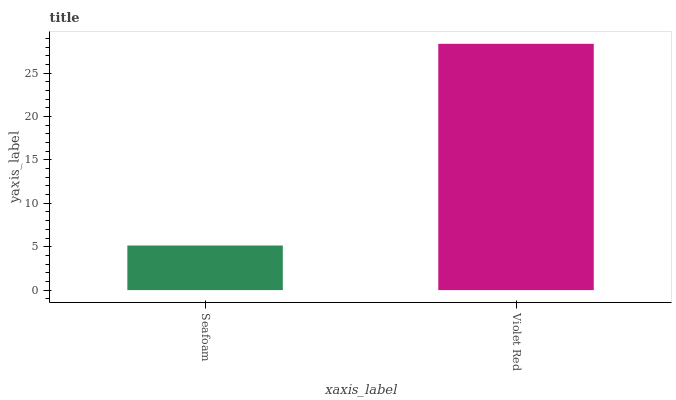Is Seafoam the minimum?
Answer yes or no. Yes. Is Violet Red the maximum?
Answer yes or no. Yes. Is Violet Red the minimum?
Answer yes or no. No. Is Violet Red greater than Seafoam?
Answer yes or no. Yes. Is Seafoam less than Violet Red?
Answer yes or no. Yes. Is Seafoam greater than Violet Red?
Answer yes or no. No. Is Violet Red less than Seafoam?
Answer yes or no. No. Is Violet Red the high median?
Answer yes or no. Yes. Is Seafoam the low median?
Answer yes or no. Yes. Is Seafoam the high median?
Answer yes or no. No. Is Violet Red the low median?
Answer yes or no. No. 